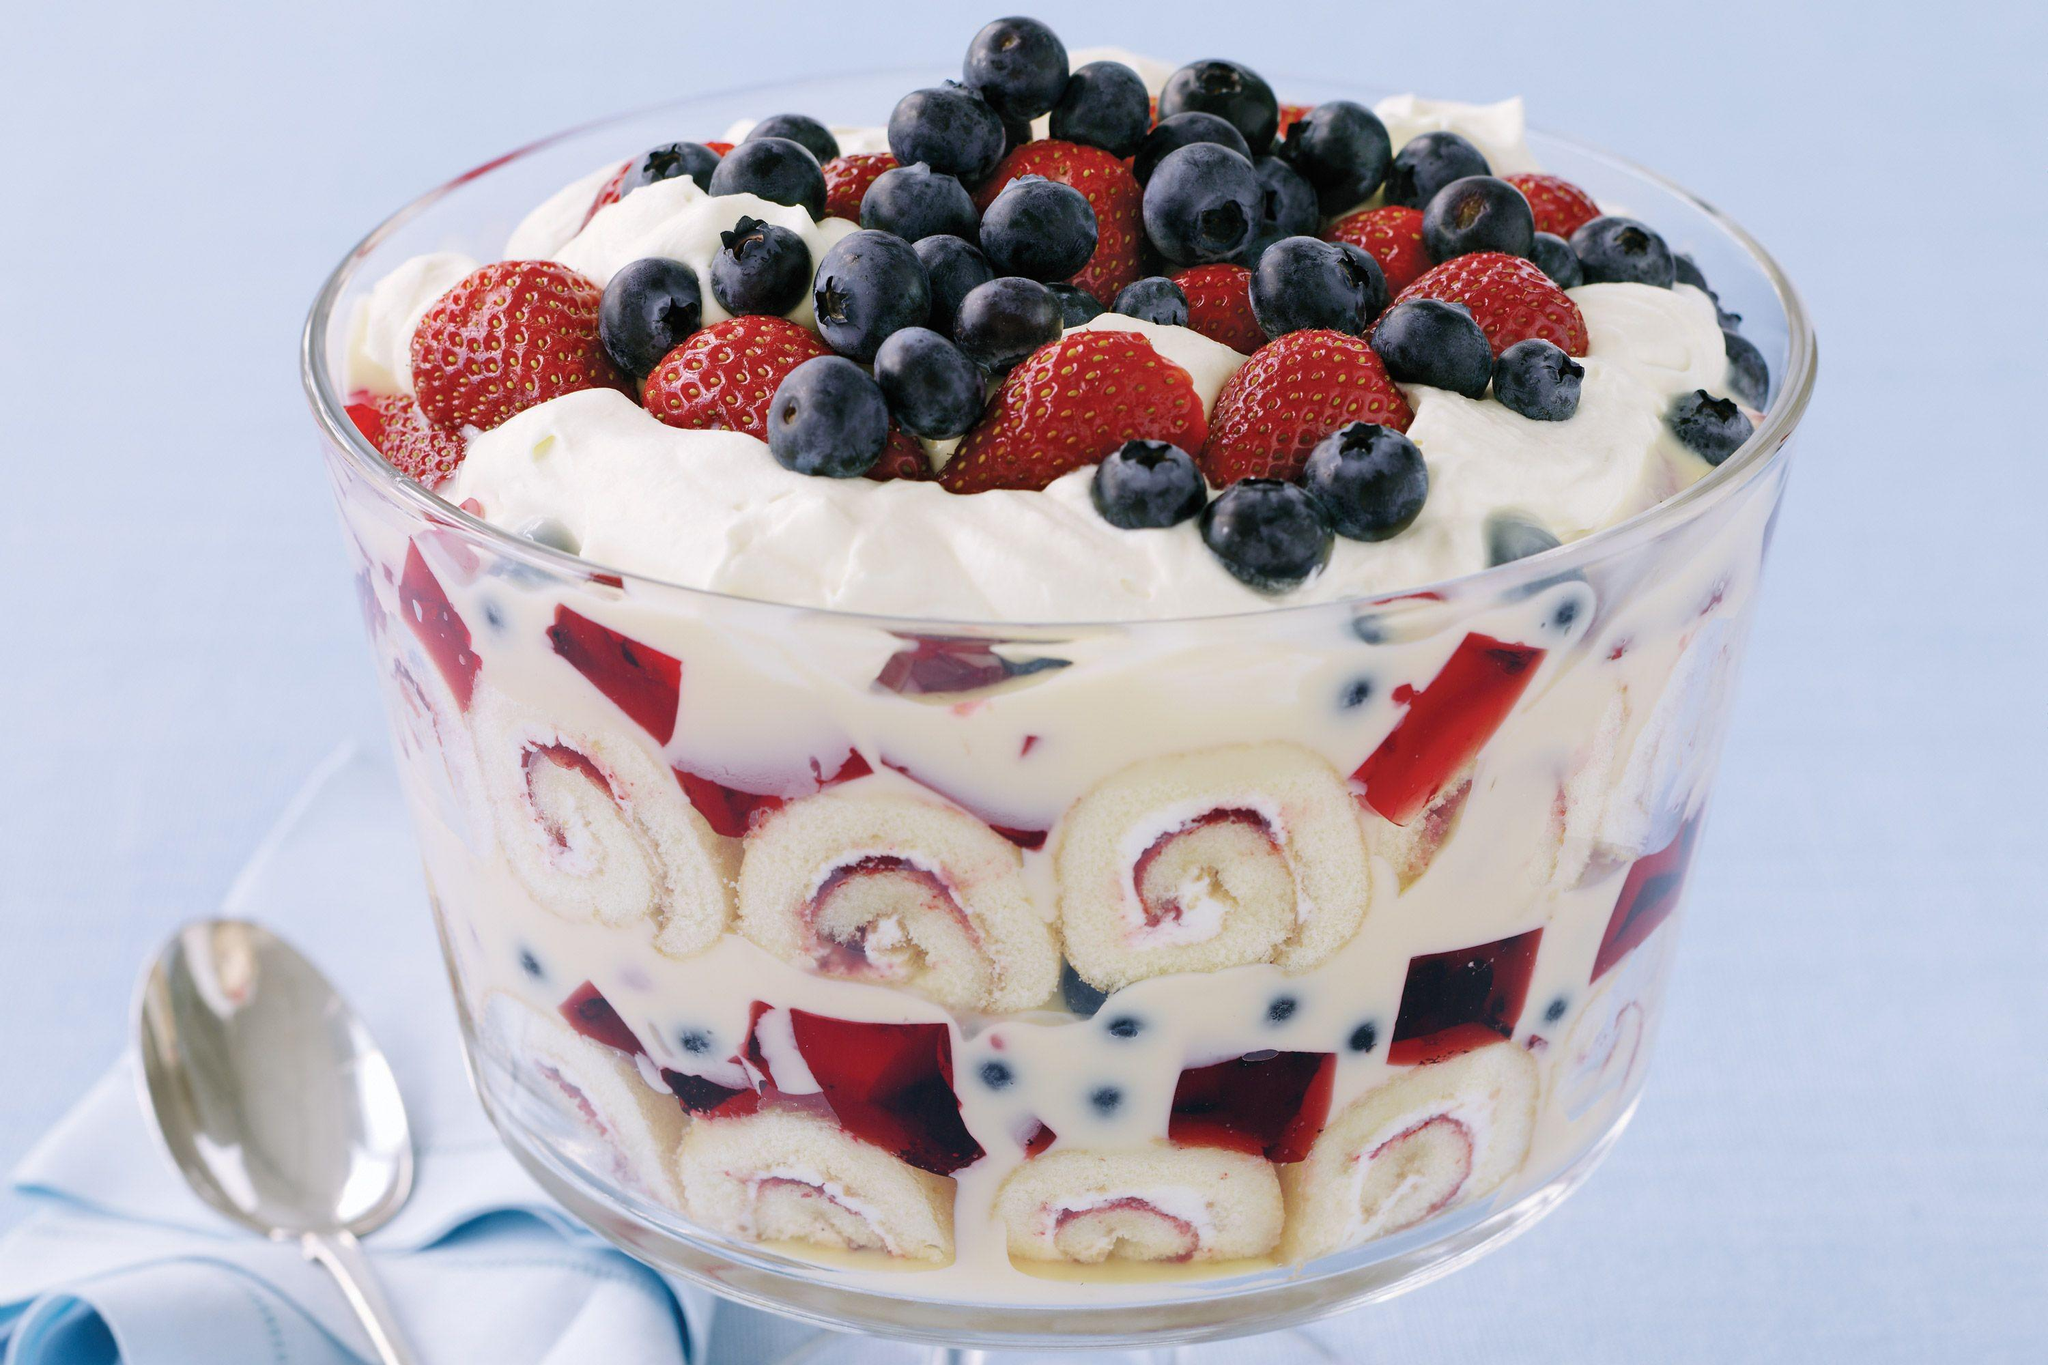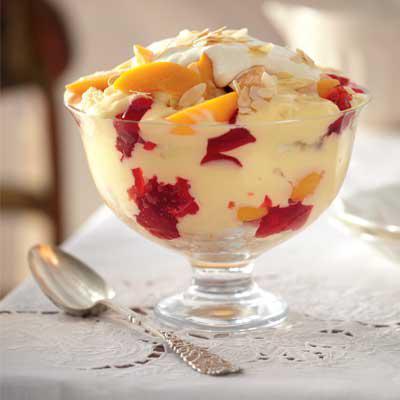The first image is the image on the left, the second image is the image on the right. For the images shown, is this caption "An image shows just one dessert bowl, topped with blueberries and strawberries." true? Answer yes or no. Yes. 